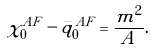Convert formula to latex. <formula><loc_0><loc_0><loc_500><loc_500>\chi _ { 0 } ^ { A F } - \bar { q } _ { 0 } ^ { A F } = \frac { m ^ { 2 } } { A } .</formula> 